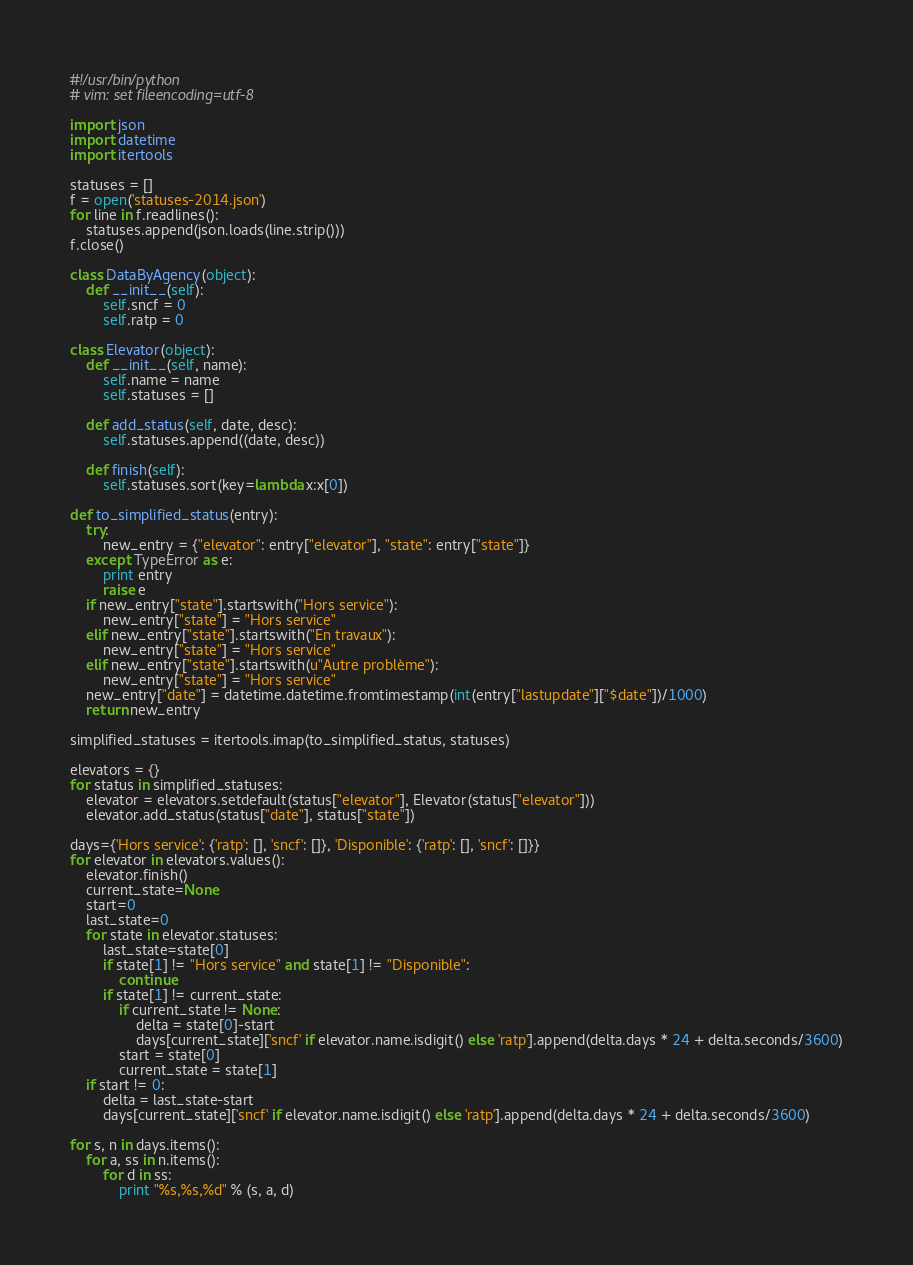<code> <loc_0><loc_0><loc_500><loc_500><_Python_>#!/usr/bin/python
# vim: set fileencoding=utf-8

import json
import datetime
import itertools

statuses = []
f = open('statuses-2014.json')
for line in f.readlines():
    statuses.append(json.loads(line.strip()))
f.close()

class DataByAgency(object):
    def __init__(self):
        self.sncf = 0
        self.ratp = 0

class Elevator(object):
    def __init__(self, name):
        self.name = name
        self.statuses = []
    
    def add_status(self, date, desc):
        self.statuses.append((date, desc))

    def finish(self):
        self.statuses.sort(key=lambda x:x[0])

def to_simplified_status(entry):
    try:
        new_entry = {"elevator": entry["elevator"], "state": entry["state"]}
    except TypeError as e:
        print entry
        raise e
    if new_entry["state"].startswith("Hors service"):
        new_entry["state"] = "Hors service"
    elif new_entry["state"].startswith("En travaux"):
        new_entry["state"] = "Hors service"
    elif new_entry["state"].startswith(u"Autre problème"):
        new_entry["state"] = "Hors service"
    new_entry["date"] = datetime.datetime.fromtimestamp(int(entry["lastupdate"]["$date"])/1000)
    return new_entry

simplified_statuses = itertools.imap(to_simplified_status, statuses)

elevators = {}
for status in simplified_statuses:
    elevator = elevators.setdefault(status["elevator"], Elevator(status["elevator"]))
    elevator.add_status(status["date"], status["state"])

days={'Hors service': {'ratp': [], 'sncf': []}, 'Disponible': {'ratp': [], 'sncf': []}}
for elevator in elevators.values():
    elevator.finish()
    current_state=None
    start=0
    last_state=0
    for state in elevator.statuses:
        last_state=state[0]
        if state[1] != "Hors service" and state[1] != "Disponible":
            continue
        if state[1] != current_state:
            if current_state != None:
                delta = state[0]-start
                days[current_state]['sncf' if elevator.name.isdigit() else 'ratp'].append(delta.days * 24 + delta.seconds/3600)
            start = state[0]
            current_state = state[1]
    if start != 0:
        delta = last_state-start
        days[current_state]['sncf' if elevator.name.isdigit() else 'ratp'].append(delta.days * 24 + delta.seconds/3600)

for s, n in days.items():
    for a, ss in n.items():
        for d in ss:
            print "%s,%s,%d" % (s, a, d)
</code> 